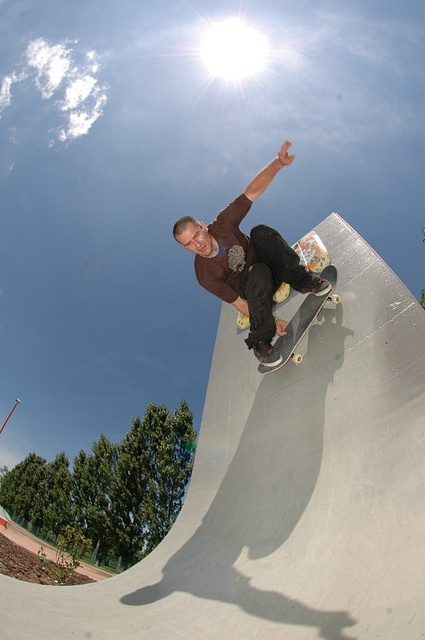Describe the objects in this image and their specific colors. I can see people in lightblue, black, maroon, brown, and gray tones and skateboard in lightblue, gray, black, and darkgray tones in this image. 